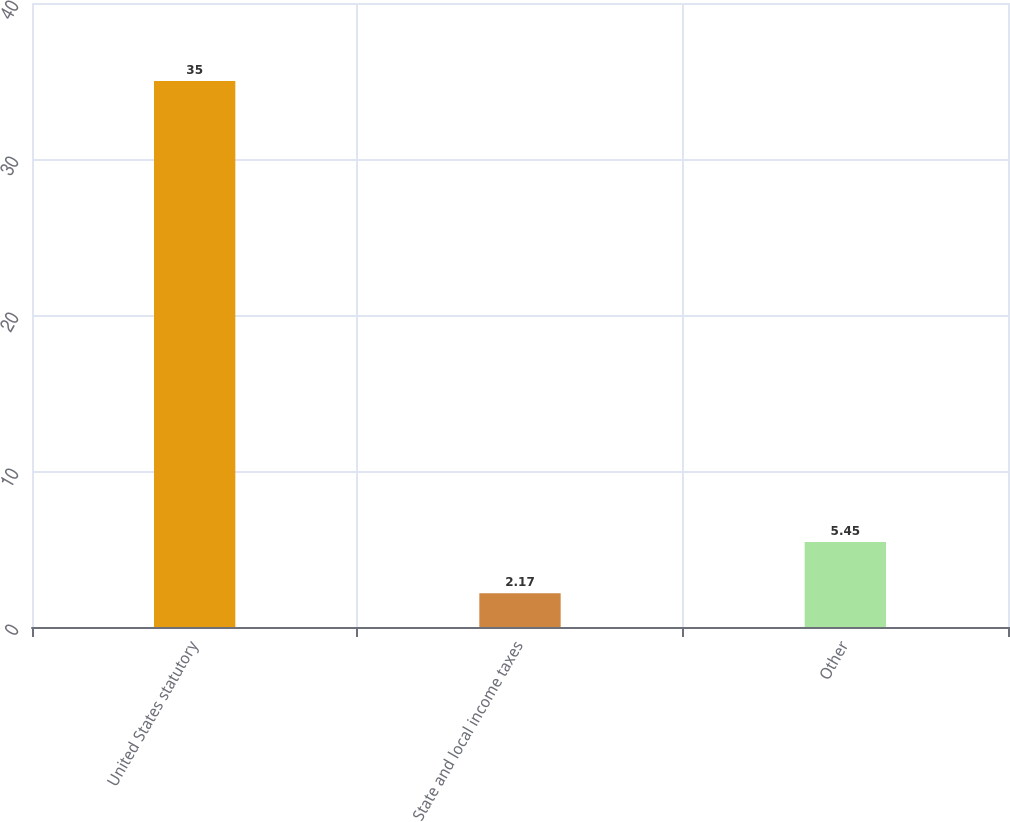Convert chart to OTSL. <chart><loc_0><loc_0><loc_500><loc_500><bar_chart><fcel>United States statutory<fcel>State and local income taxes<fcel>Other<nl><fcel>35<fcel>2.17<fcel>5.45<nl></chart> 